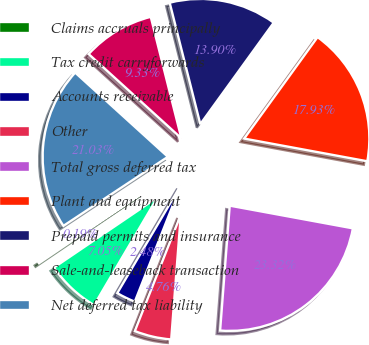Convert chart. <chart><loc_0><loc_0><loc_500><loc_500><pie_chart><fcel>Claims accruals principally<fcel>Tax credit carryforwards<fcel>Accounts receivable<fcel>Other<fcel>Total gross deferred tax<fcel>Plant and equipment<fcel>Prepaid permits and insurance<fcel>Sale-and-leaseback transaction<fcel>Net deferred tax liability<nl><fcel>0.19%<fcel>7.05%<fcel>2.48%<fcel>4.76%<fcel>23.32%<fcel>17.93%<fcel>13.9%<fcel>9.33%<fcel>21.03%<nl></chart> 